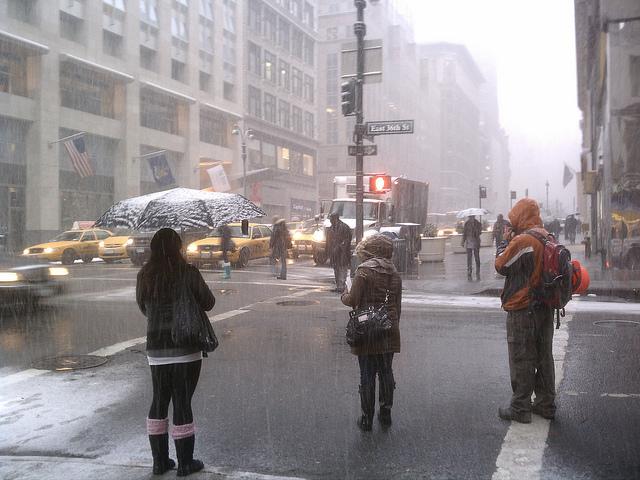What are the yellow cars called?
Quick response, please. Taxi. Is it raining?
Keep it brief. Yes. How many people are standing in the cross walk?
Concise answer only. 3. 